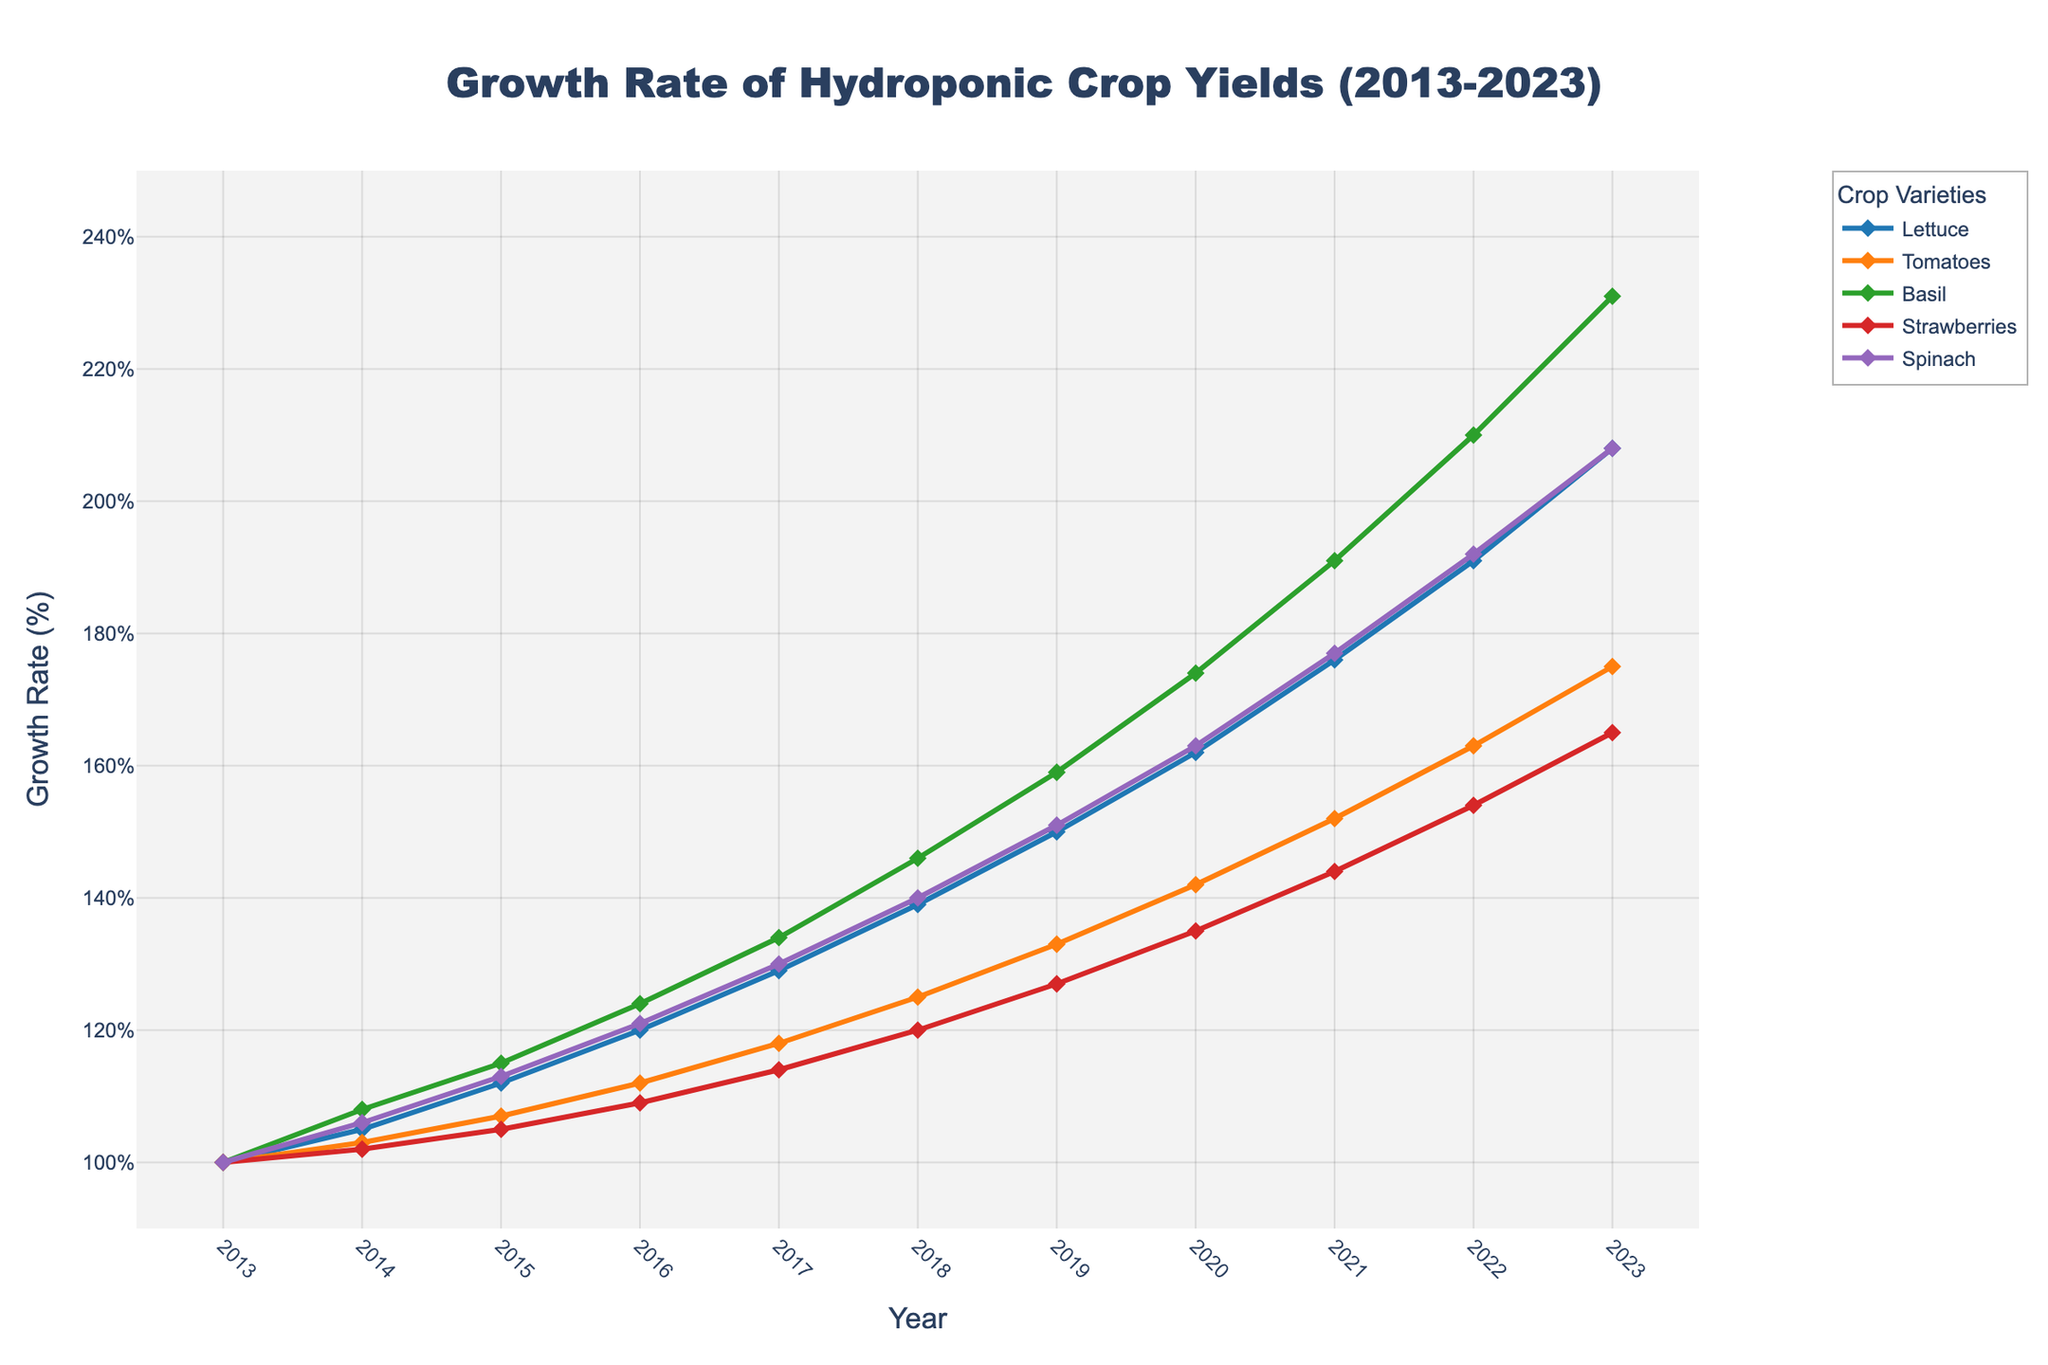What is the growth rate of Basil in 2020? Look at the value for Basil in 2020. The growth rate for Basil in 2020 is listed as 174%
Answer: 174% Which crop had the highest growth rate in 2023? Find the highest value for the year 2023 among all the crops. Basil had the highest growth rate at 231%
Answer: Basil How much did the growth rate of Lettuce increase from 2013 to 2023? Subtract the growth rate of Lettuce in 2013 from that in 2023: 208% - 100% = 108%
Answer: 108% Which crop varieties experienced more than a 100% increase in their growth rates between 2013 and 2023? Calculate the difference between 2023 and 2013 for each crop. All crops (Lettuce, Tomatoes, Basil, Strawberries, Spinach) experienced an increase greater than 100%
Answer: Lettuce, Tomatoes, Basil, Strawberries, Spinach Which crop had a lower growth rate in 2019 compared to Tomatoes? Compare the 2019 growth rate of Tomatoes with other crops for 2019. Strawberries had a lower rate at 127% compared to Tomatoes at 133%
Answer: Strawberries In what year did Basil surpass the 200% growth rate? Look through the years in the Basil line until you find the first year exceeding 200%. In 2022, Basil reached 210%.
Answer: 2022 What was the average growth rate of Spinach from 2013 to 2023? Sum all the Spinach values and divide by the number of years: (100 + 106 + 113 + 121 + 130 + 140 + 151 + 163 + 177 + 192 + 208) / 11 ≈ 142.5%
Answer: 142.5% Between 2017 and 2020, which crop showed the highest increase in its growth rate? For each crop, subtract the 2017 value from the 2020 value and find the maximum: Basil = 174% - 134% = 40%, the highest amongst all the crops
Answer: Basil Which crop has the steepest slope in its growth curve between 2015 and 2016? Identify which crop has the largest difference between 2015 and 2016. Basil increased from 115% to 124%, a difference of 9%, which is the largest
Answer: Basil 